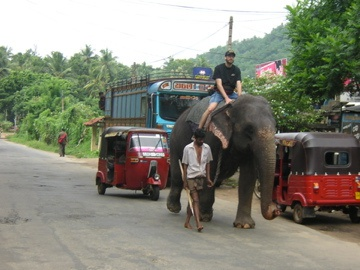Describe the objects in this image and their specific colors. I can see elephant in white, black, and gray tones, car in white, black, brown, maroon, and gray tones, truck in white, gray, black, purple, and darkgray tones, bus in white, gray, black, purple, and darkgray tones, and people in white, darkgray, black, and gray tones in this image. 